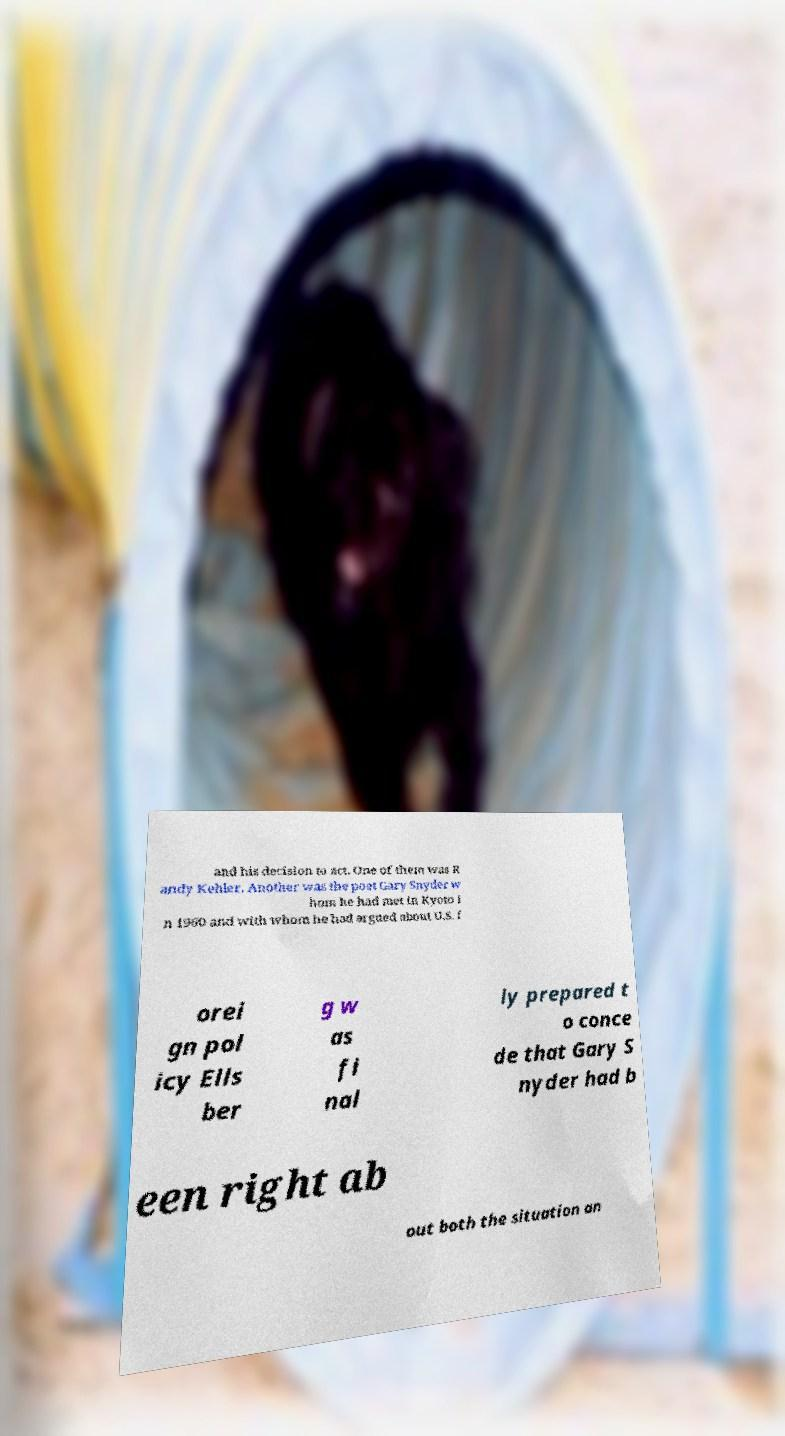Please identify and transcribe the text found in this image. and his decision to act. One of them was R andy Kehler. Another was the poet Gary Snyder w hom he had met in Kyoto i n 1960 and with whom he had argued about U.S. f orei gn pol icy Ells ber g w as fi nal ly prepared t o conce de that Gary S nyder had b een right ab out both the situation an 